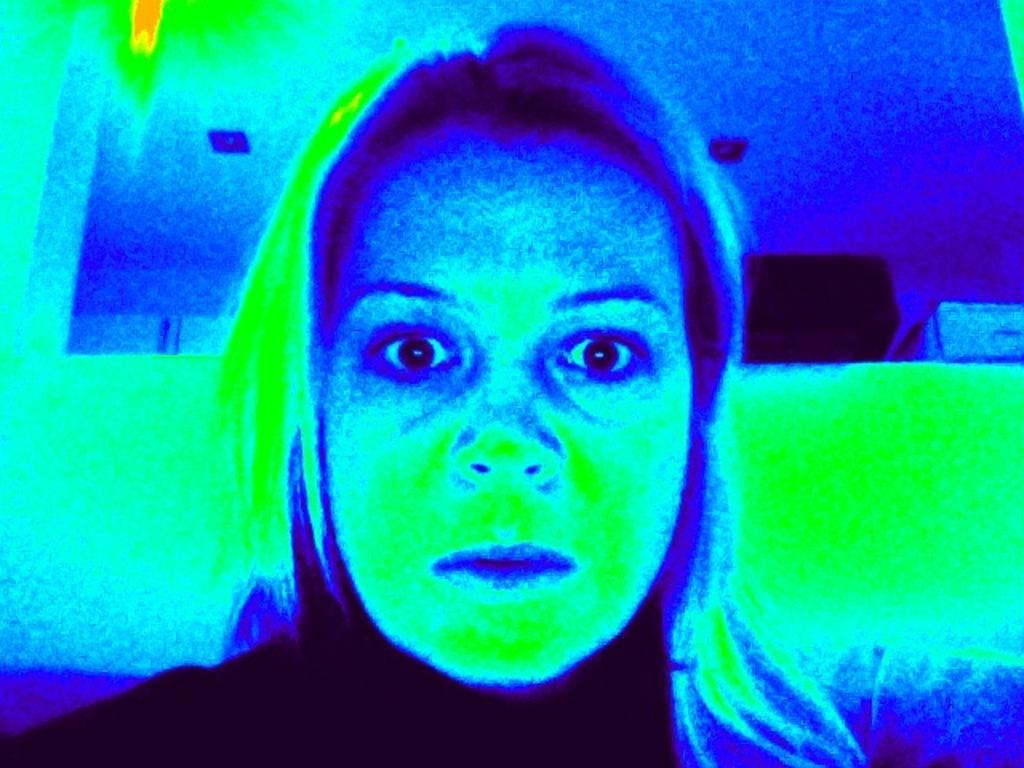How was the image altered or modified? The image is edited. What is the main subject in the image? There is a girl in the middle of the image. What can be seen behind the girl in the image? There is a wall in the background of the image, along with a few objects. What is visible at the top of the image? There is a roof visible at the top of the image. What type of popcorn is being sold in the alley behind the girl in the image? There is no alley or popcorn present in the image. What degree does the girl in the image have in computer science? The image does not provide any information about the girl's education or degree in computer science. 